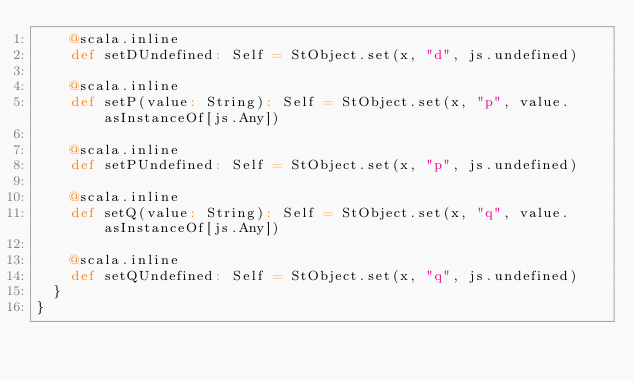Convert code to text. <code><loc_0><loc_0><loc_500><loc_500><_Scala_>    @scala.inline
    def setDUndefined: Self = StObject.set(x, "d", js.undefined)
    
    @scala.inline
    def setP(value: String): Self = StObject.set(x, "p", value.asInstanceOf[js.Any])
    
    @scala.inline
    def setPUndefined: Self = StObject.set(x, "p", js.undefined)
    
    @scala.inline
    def setQ(value: String): Self = StObject.set(x, "q", value.asInstanceOf[js.Any])
    
    @scala.inline
    def setQUndefined: Self = StObject.set(x, "q", js.undefined)
  }
}
</code> 